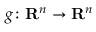Convert formula to latex. <formula><loc_0><loc_0><loc_500><loc_500>g \colon R ^ { n } \to R ^ { n }</formula> 